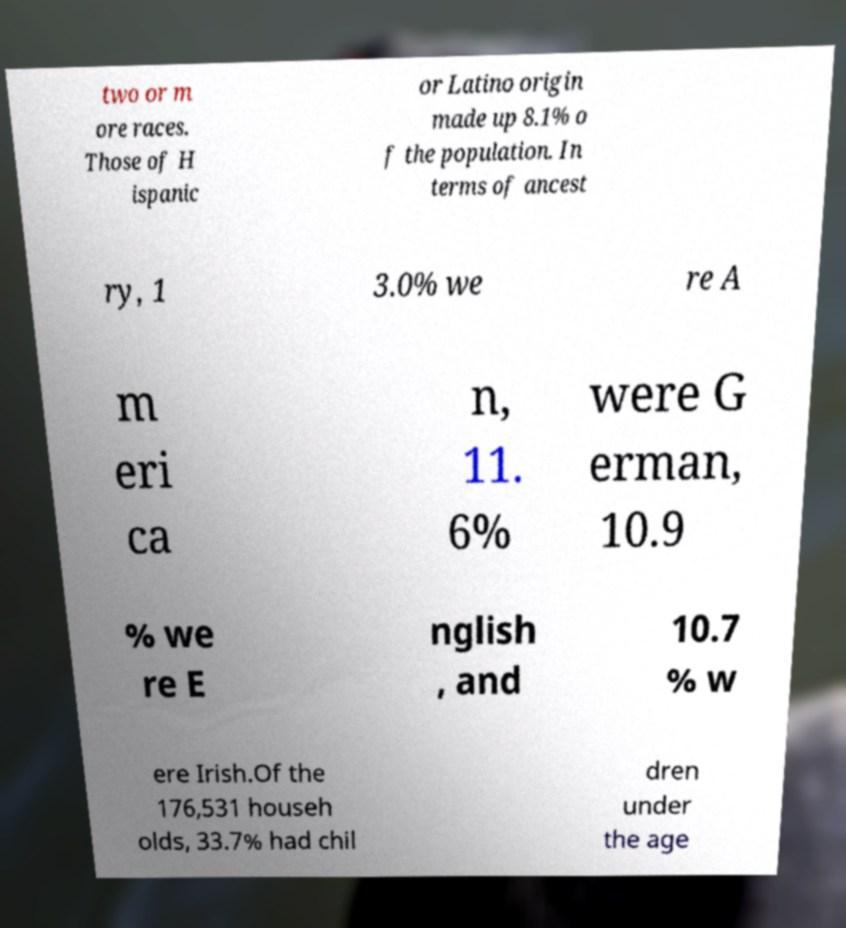There's text embedded in this image that I need extracted. Can you transcribe it verbatim? two or m ore races. Those of H ispanic or Latino origin made up 8.1% o f the population. In terms of ancest ry, 1 3.0% we re A m eri ca n, 11. 6% were G erman, 10.9 % we re E nglish , and 10.7 % w ere Irish.Of the 176,531 househ olds, 33.7% had chil dren under the age 